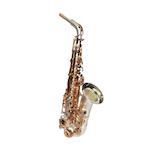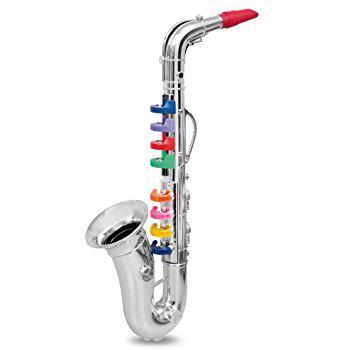The first image is the image on the left, the second image is the image on the right. Evaluate the accuracy of this statement regarding the images: "The right image contains a human child playing a saxophone.". Is it true? Answer yes or no. No. The first image is the image on the left, the second image is the image on the right. Examine the images to the left and right. Is the description "In one image, a child wearing jeans is leaning back as he or she plays a saxophone." accurate? Answer yes or no. No. 